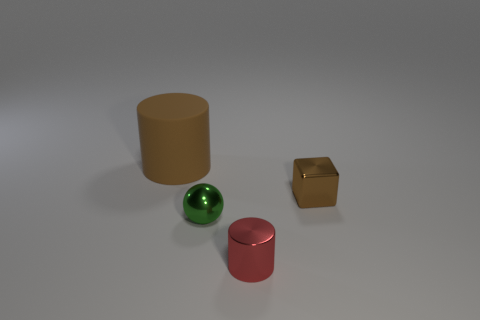Is there any other thing that is the same material as the big brown cylinder?
Your response must be concise. No. Are there any blocks that have the same color as the big rubber cylinder?
Offer a terse response. Yes. There is a small object that is both behind the small red metallic cylinder and left of the shiny block; what is its shape?
Keep it short and to the point. Sphere. There is a tiny shiny thing to the left of the cylinder that is in front of the tiny brown metal block; what shape is it?
Offer a very short reply. Sphere. Is the large brown object the same shape as the green thing?
Provide a short and direct response. No. There is a big object that is the same color as the tiny metal cube; what is its material?
Give a very brief answer. Rubber. Does the metallic cylinder have the same color as the metal sphere?
Your answer should be very brief. No. What number of small metal cylinders are on the left side of the cylinder in front of the cylinder that is behind the tiny red cylinder?
Offer a very short reply. 0. The small green object that is the same material as the red cylinder is what shape?
Ensure brevity in your answer.  Sphere. What material is the brown object on the left side of the cylinder that is in front of the cube that is on the right side of the ball made of?
Your answer should be very brief. Rubber. 